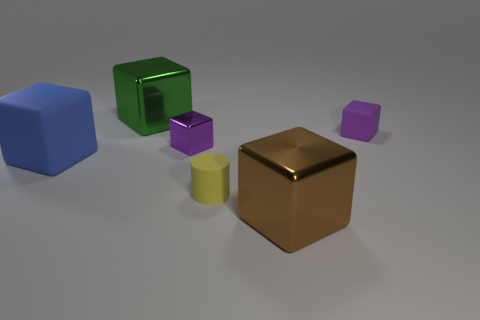What number of purple blocks are the same material as the yellow thing?
Provide a short and direct response. 1. Is the material of the big object that is behind the tiny purple rubber thing the same as the big brown thing?
Your answer should be very brief. Yes. Are there the same number of small purple metallic cubes that are behind the large green thing and green metallic cylinders?
Your answer should be compact. Yes. What size is the yellow cylinder?
Make the answer very short. Small. There is a tiny block that is the same color as the tiny shiny thing; what material is it?
Provide a succinct answer. Rubber. How many tiny matte blocks have the same color as the small shiny block?
Make the answer very short. 1. Is the yellow rubber object the same size as the green thing?
Offer a very short reply. No. There is a purple cube on the left side of the small purple cube that is to the right of the yellow thing; how big is it?
Provide a short and direct response. Small. Does the large matte object have the same color as the large cube that is behind the tiny metallic block?
Offer a terse response. No. Is there a purple metal object of the same size as the blue matte block?
Your response must be concise. No. 